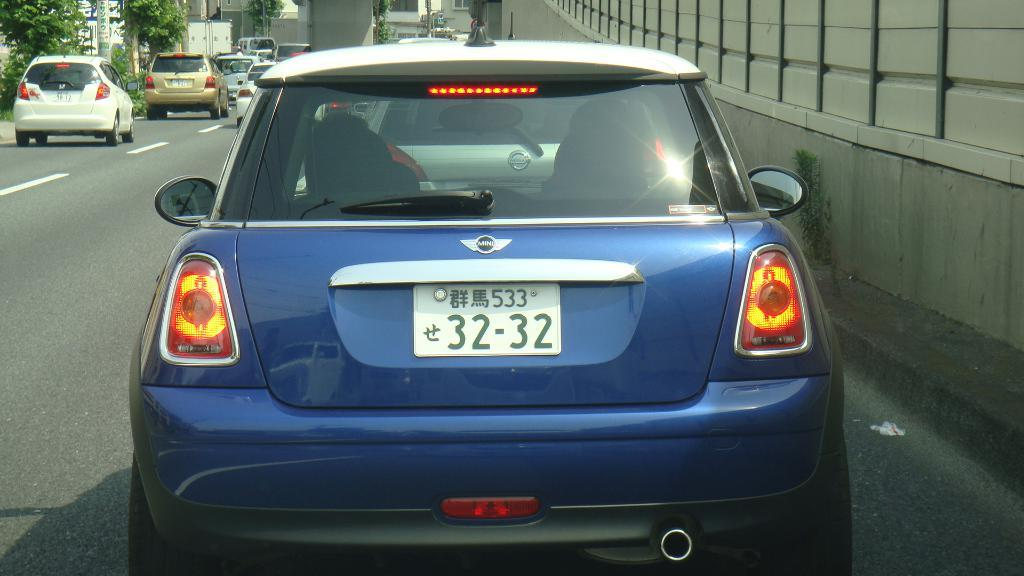What can be seen on the road in the image? There are vehicles on the road in the image. What type of natural elements can be seen in the background of the image? Trees are visible in the background of the image. What type of man-made structures can be seen in the background of the image? There are buildings in the background of the image. What type of vertical structures can be seen in the background of the image? Poles are present in the background of the image. What type of signage can be seen in the background of the image? Banners are present in the background of the image. What type of metal can be seen in the image? There is no specific mention of metal in the image, so it cannot be determined what type of metal might be present. What type of drink is being consumed by the people in the image? There are no people or drinks visible in the image. 